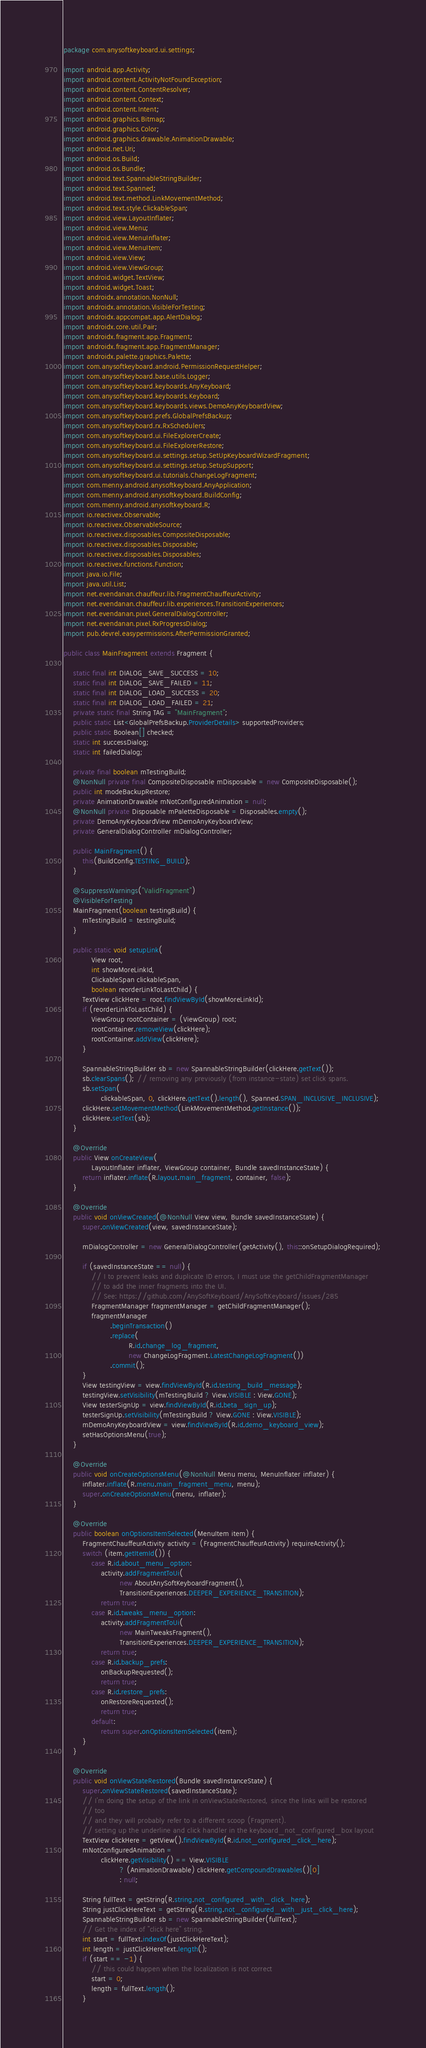Convert code to text. <code><loc_0><loc_0><loc_500><loc_500><_Java_>package com.anysoftkeyboard.ui.settings;

import android.app.Activity;
import android.content.ActivityNotFoundException;
import android.content.ContentResolver;
import android.content.Context;
import android.content.Intent;
import android.graphics.Bitmap;
import android.graphics.Color;
import android.graphics.drawable.AnimationDrawable;
import android.net.Uri;
import android.os.Build;
import android.os.Bundle;
import android.text.SpannableStringBuilder;
import android.text.Spanned;
import android.text.method.LinkMovementMethod;
import android.text.style.ClickableSpan;
import android.view.LayoutInflater;
import android.view.Menu;
import android.view.MenuInflater;
import android.view.MenuItem;
import android.view.View;
import android.view.ViewGroup;
import android.widget.TextView;
import android.widget.Toast;
import androidx.annotation.NonNull;
import androidx.annotation.VisibleForTesting;
import androidx.appcompat.app.AlertDialog;
import androidx.core.util.Pair;
import androidx.fragment.app.Fragment;
import androidx.fragment.app.FragmentManager;
import androidx.palette.graphics.Palette;
import com.anysoftkeyboard.android.PermissionRequestHelper;
import com.anysoftkeyboard.base.utils.Logger;
import com.anysoftkeyboard.keyboards.AnyKeyboard;
import com.anysoftkeyboard.keyboards.Keyboard;
import com.anysoftkeyboard.keyboards.views.DemoAnyKeyboardView;
import com.anysoftkeyboard.prefs.GlobalPrefsBackup;
import com.anysoftkeyboard.rx.RxSchedulers;
import com.anysoftkeyboard.ui.FileExplorerCreate;
import com.anysoftkeyboard.ui.FileExplorerRestore;
import com.anysoftkeyboard.ui.settings.setup.SetUpKeyboardWizardFragment;
import com.anysoftkeyboard.ui.settings.setup.SetupSupport;
import com.anysoftkeyboard.ui.tutorials.ChangeLogFragment;
import com.menny.android.anysoftkeyboard.AnyApplication;
import com.menny.android.anysoftkeyboard.BuildConfig;
import com.menny.android.anysoftkeyboard.R;
import io.reactivex.Observable;
import io.reactivex.ObservableSource;
import io.reactivex.disposables.CompositeDisposable;
import io.reactivex.disposables.Disposable;
import io.reactivex.disposables.Disposables;
import io.reactivex.functions.Function;
import java.io.File;
import java.util.List;
import net.evendanan.chauffeur.lib.FragmentChauffeurActivity;
import net.evendanan.chauffeur.lib.experiences.TransitionExperiences;
import net.evendanan.pixel.GeneralDialogController;
import net.evendanan.pixel.RxProgressDialog;
import pub.devrel.easypermissions.AfterPermissionGranted;

public class MainFragment extends Fragment {

    static final int DIALOG_SAVE_SUCCESS = 10;
    static final int DIALOG_SAVE_FAILED = 11;
    static final int DIALOG_LOAD_SUCCESS = 20;
    static final int DIALOG_LOAD_FAILED = 21;
    private static final String TAG = "MainFragment";
    public static List<GlobalPrefsBackup.ProviderDetails> supportedProviders;
    public static Boolean[] checked;
    static int successDialog;
    static int failedDialog;

    private final boolean mTestingBuild;
    @NonNull private final CompositeDisposable mDisposable = new CompositeDisposable();
    public int modeBackupRestore;
    private AnimationDrawable mNotConfiguredAnimation = null;
    @NonNull private Disposable mPaletteDisposable = Disposables.empty();
    private DemoAnyKeyboardView mDemoAnyKeyboardView;
    private GeneralDialogController mDialogController;

    public MainFragment() {
        this(BuildConfig.TESTING_BUILD);
    }

    @SuppressWarnings("ValidFragment")
    @VisibleForTesting
    MainFragment(boolean testingBuild) {
        mTestingBuild = testingBuild;
    }

    public static void setupLink(
            View root,
            int showMoreLinkId,
            ClickableSpan clickableSpan,
            boolean reorderLinkToLastChild) {
        TextView clickHere = root.findViewById(showMoreLinkId);
        if (reorderLinkToLastChild) {
            ViewGroup rootContainer = (ViewGroup) root;
            rootContainer.removeView(clickHere);
            rootContainer.addView(clickHere);
        }

        SpannableStringBuilder sb = new SpannableStringBuilder(clickHere.getText());
        sb.clearSpans(); // removing any previously (from instance-state) set click spans.
        sb.setSpan(
                clickableSpan, 0, clickHere.getText().length(), Spanned.SPAN_INCLUSIVE_INCLUSIVE);
        clickHere.setMovementMethod(LinkMovementMethod.getInstance());
        clickHere.setText(sb);
    }

    @Override
    public View onCreateView(
            LayoutInflater inflater, ViewGroup container, Bundle savedInstanceState) {
        return inflater.inflate(R.layout.main_fragment, container, false);
    }

    @Override
    public void onViewCreated(@NonNull View view, Bundle savedInstanceState) {
        super.onViewCreated(view, savedInstanceState);

        mDialogController = new GeneralDialogController(getActivity(), this::onSetupDialogRequired);

        if (savedInstanceState == null) {
            // I to prevent leaks and duplicate ID errors, I must use the getChildFragmentManager
            // to add the inner fragments into the UI.
            // See: https://github.com/AnySoftKeyboard/AnySoftKeyboard/issues/285
            FragmentManager fragmentManager = getChildFragmentManager();
            fragmentManager
                    .beginTransaction()
                    .replace(
                            R.id.change_log_fragment,
                            new ChangeLogFragment.LatestChangeLogFragment())
                    .commit();
        }
        View testingView = view.findViewById(R.id.testing_build_message);
        testingView.setVisibility(mTestingBuild ? View.VISIBLE : View.GONE);
        View testerSignUp = view.findViewById(R.id.beta_sign_up);
        testerSignUp.setVisibility(mTestingBuild ? View.GONE : View.VISIBLE);
        mDemoAnyKeyboardView = view.findViewById(R.id.demo_keyboard_view);
        setHasOptionsMenu(true);
    }

    @Override
    public void onCreateOptionsMenu(@NonNull Menu menu, MenuInflater inflater) {
        inflater.inflate(R.menu.main_fragment_menu, menu);
        super.onCreateOptionsMenu(menu, inflater);
    }

    @Override
    public boolean onOptionsItemSelected(MenuItem item) {
        FragmentChauffeurActivity activity = (FragmentChauffeurActivity) requireActivity();
        switch (item.getItemId()) {
            case R.id.about_menu_option:
                activity.addFragmentToUi(
                        new AboutAnySoftKeyboardFragment(),
                        TransitionExperiences.DEEPER_EXPERIENCE_TRANSITION);
                return true;
            case R.id.tweaks_menu_option:
                activity.addFragmentToUi(
                        new MainTweaksFragment(),
                        TransitionExperiences.DEEPER_EXPERIENCE_TRANSITION);
                return true;
            case R.id.backup_prefs:
                onBackupRequested();
                return true;
            case R.id.restore_prefs:
                onRestoreRequested();
                return true;
            default:
                return super.onOptionsItemSelected(item);
        }
    }

    @Override
    public void onViewStateRestored(Bundle savedInstanceState) {
        super.onViewStateRestored(savedInstanceState);
        // I'm doing the setup of the link in onViewStateRestored, since the links will be restored
        // too
        // and they will probably refer to a different scoop (Fragment).
        // setting up the underline and click handler in the keyboard_not_configured_box layout
        TextView clickHere = getView().findViewById(R.id.not_configured_click_here);
        mNotConfiguredAnimation =
                clickHere.getVisibility() == View.VISIBLE
                        ? (AnimationDrawable) clickHere.getCompoundDrawables()[0]
                        : null;

        String fullText = getString(R.string.not_configured_with_click_here);
        String justClickHereText = getString(R.string.not_configured_with_just_click_here);
        SpannableStringBuilder sb = new SpannableStringBuilder(fullText);
        // Get the index of "click here" string.
        int start = fullText.indexOf(justClickHereText);
        int length = justClickHereText.length();
        if (start == -1) {
            // this could happen when the localization is not correct
            start = 0;
            length = fullText.length();
        }</code> 